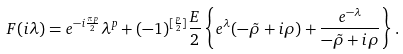<formula> <loc_0><loc_0><loc_500><loc_500>F ( i \lambda ) = e ^ { - i \frac { \pi p } 2 } \lambda ^ { p } + ( - 1 ) ^ { [ \frac { p } { 2 } ] } \frac { E } { 2 } \left \{ e ^ { \lambda } ( - \tilde { \rho } + i \rho ) + \frac { e ^ { - \lambda } } { - \tilde { \rho } + i \rho } \right \} .</formula> 